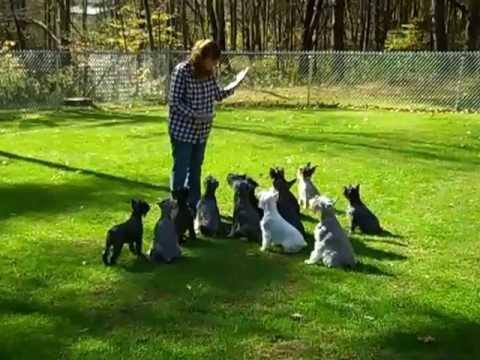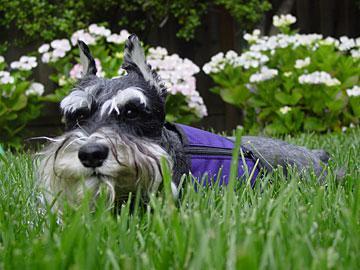The first image is the image on the left, the second image is the image on the right. Evaluate the accuracy of this statement regarding the images: "A person is standing with a group of dogs in the image on the left.". Is it true? Answer yes or no. Yes. The first image is the image on the left, the second image is the image on the right. Examine the images to the left and right. Is the description "An image shows one schnauzer in the grass, with planted blooming flowers behind the dog but not in front of it." accurate? Answer yes or no. Yes. 